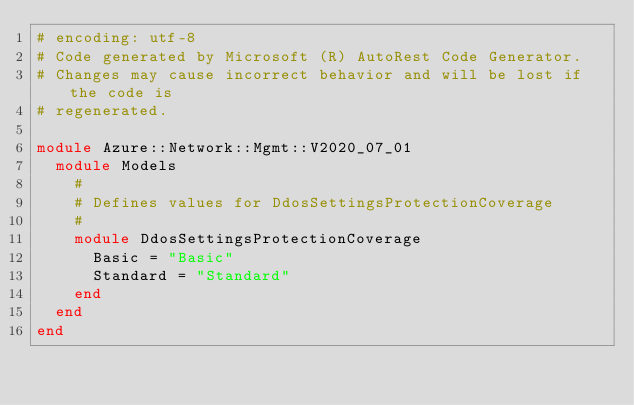<code> <loc_0><loc_0><loc_500><loc_500><_Ruby_># encoding: utf-8
# Code generated by Microsoft (R) AutoRest Code Generator.
# Changes may cause incorrect behavior and will be lost if the code is
# regenerated.

module Azure::Network::Mgmt::V2020_07_01
  module Models
    #
    # Defines values for DdosSettingsProtectionCoverage
    #
    module DdosSettingsProtectionCoverage
      Basic = "Basic"
      Standard = "Standard"
    end
  end
end
</code> 